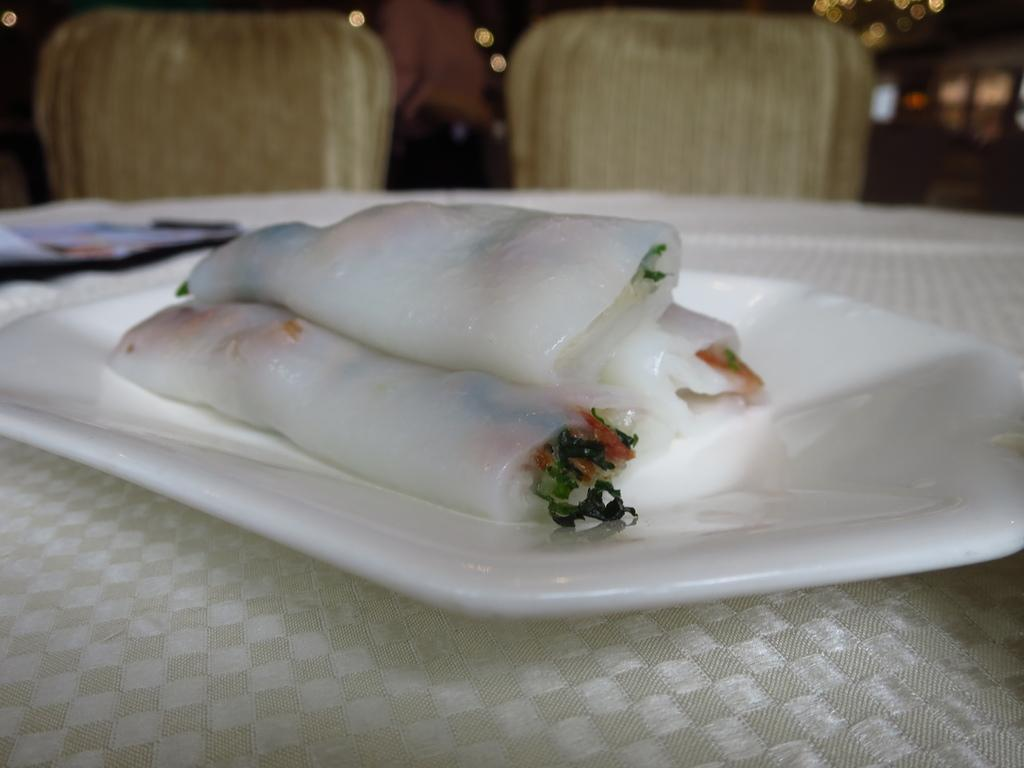What piece of furniture is present in the image? There is a table in the image. What is placed on the table? There is a white color plate on the table. What is on the plate? There is a food item on the plate. How many chairs are visible in the image? There are two chairs behind the table. How many rings are visible on the food item in the image? There are no rings present on the food item in the image. What type of grip is required to hold the table in the image? The table is stationary and does not require any grip to hold it. 